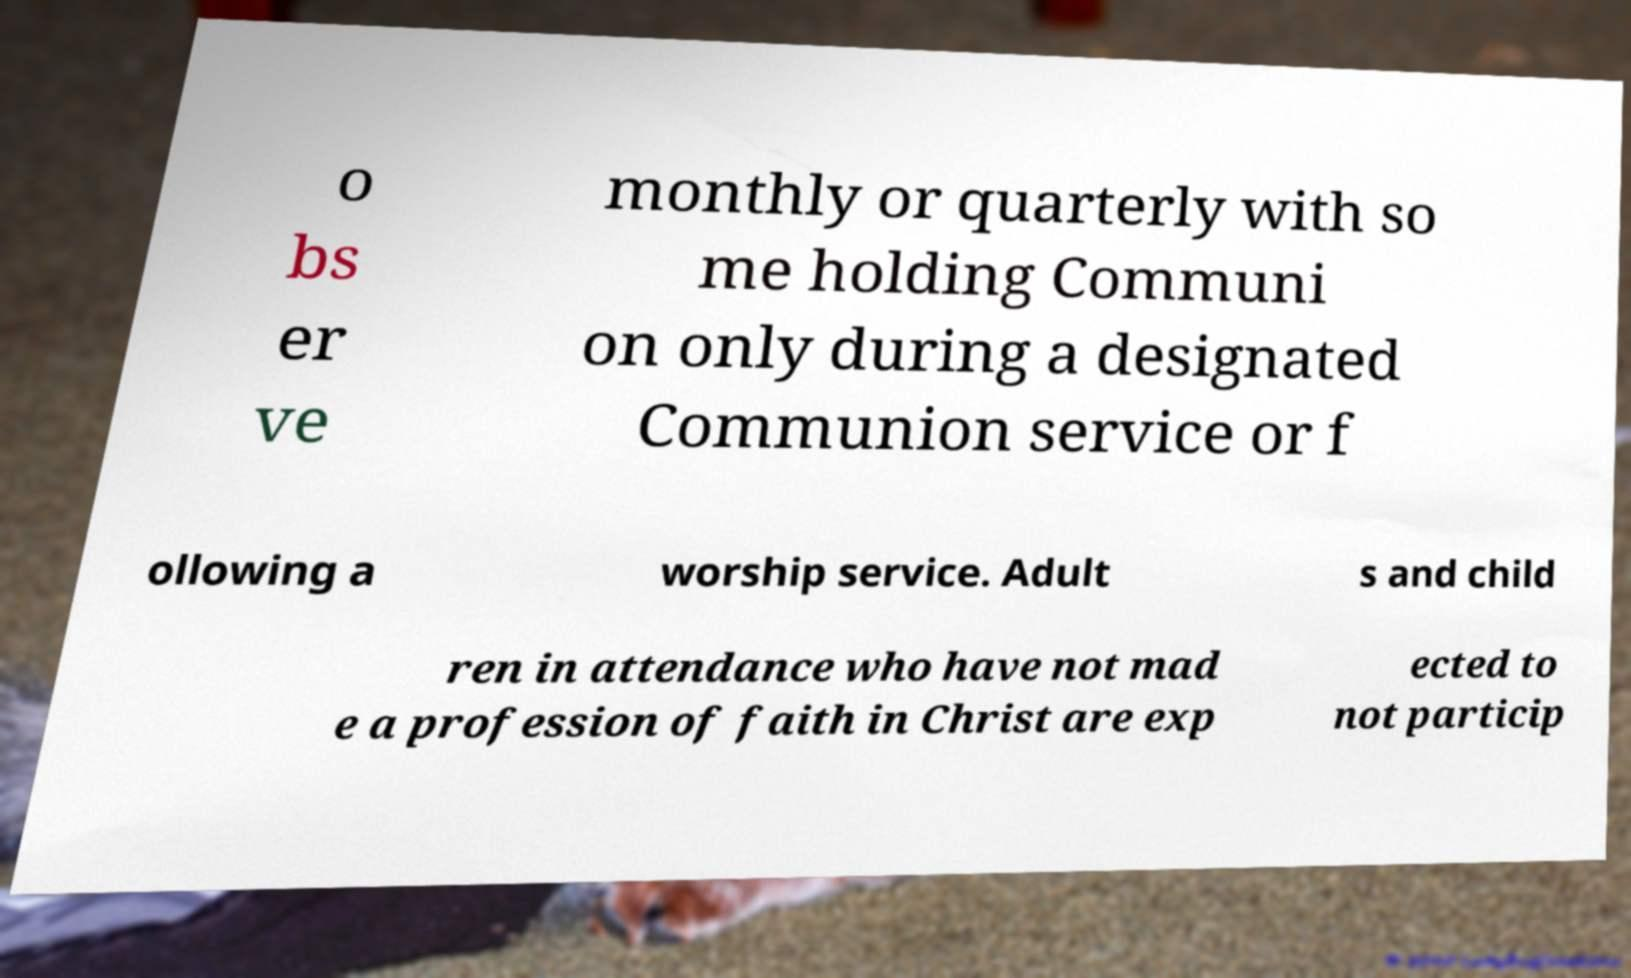Can you read and provide the text displayed in the image?This photo seems to have some interesting text. Can you extract and type it out for me? o bs er ve monthly or quarterly with so me holding Communi on only during a designated Communion service or f ollowing a worship service. Adult s and child ren in attendance who have not mad e a profession of faith in Christ are exp ected to not particip 